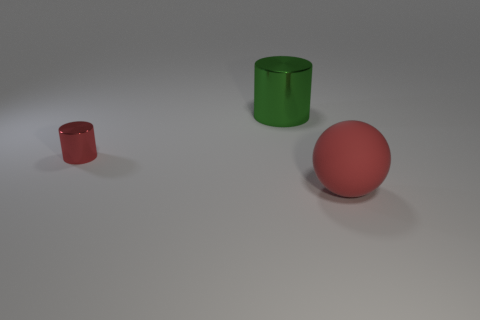Is the cylinder that is behind the small object made of the same material as the cylinder that is left of the green cylinder?
Your answer should be compact. Yes. Are there the same number of green things that are in front of the red cylinder and tiny metal cylinders to the right of the big ball?
Provide a succinct answer. Yes. The shiny object that is the same size as the red matte object is what color?
Provide a short and direct response. Green. Are there any big metallic things of the same color as the big metal cylinder?
Give a very brief answer. No. What number of objects are shiny objects behind the red shiny object or gray blocks?
Provide a succinct answer. 1. How many other things are the same size as the matte sphere?
Your response must be concise. 1. The object that is behind the metal cylinder in front of the metal cylinder behind the small red metal object is made of what material?
Your response must be concise. Metal. How many cylinders are either metal things or brown metal objects?
Provide a succinct answer. 2. Is there anything else that is the same shape as the green thing?
Provide a succinct answer. Yes. Are there more tiny red shiny cylinders that are in front of the large green metallic cylinder than tiny red shiny cylinders that are in front of the small cylinder?
Ensure brevity in your answer.  Yes. 